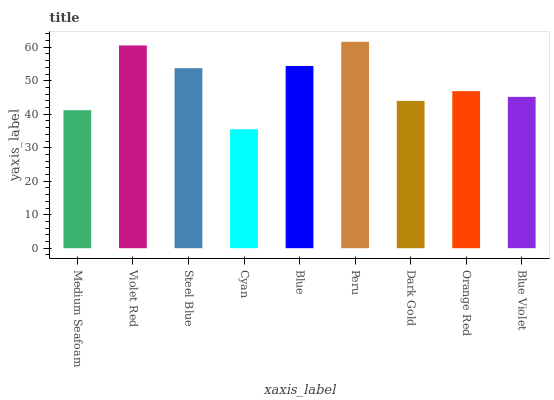Is Violet Red the minimum?
Answer yes or no. No. Is Violet Red the maximum?
Answer yes or no. No. Is Violet Red greater than Medium Seafoam?
Answer yes or no. Yes. Is Medium Seafoam less than Violet Red?
Answer yes or no. Yes. Is Medium Seafoam greater than Violet Red?
Answer yes or no. No. Is Violet Red less than Medium Seafoam?
Answer yes or no. No. Is Orange Red the high median?
Answer yes or no. Yes. Is Orange Red the low median?
Answer yes or no. Yes. Is Violet Red the high median?
Answer yes or no. No. Is Medium Seafoam the low median?
Answer yes or no. No. 